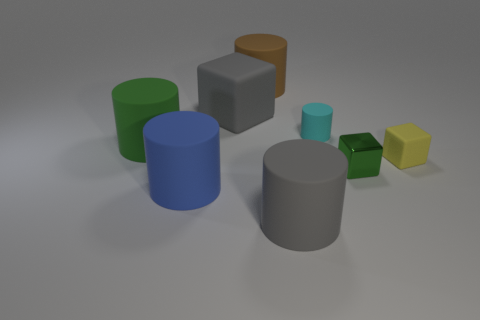Subtract all gray cylinders. How many cylinders are left? 4 Subtract all gray cylinders. How many cylinders are left? 4 Subtract all yellow cylinders. Subtract all red spheres. How many cylinders are left? 5 Add 1 small cyan shiny objects. How many objects exist? 9 Subtract all cubes. How many objects are left? 5 Subtract all big gray rubber cylinders. Subtract all large brown rubber cylinders. How many objects are left? 6 Add 7 yellow rubber blocks. How many yellow rubber blocks are left? 8 Add 5 tiny brown matte spheres. How many tiny brown matte spheres exist? 5 Subtract 0 brown spheres. How many objects are left? 8 